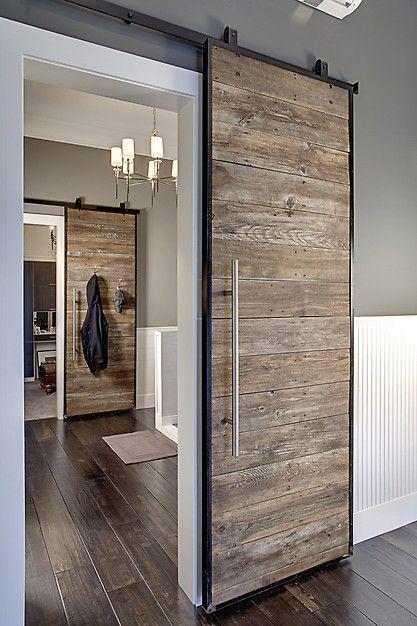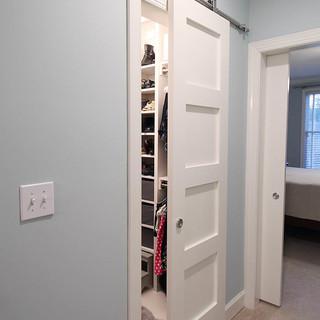The first image is the image on the left, the second image is the image on the right. For the images displayed, is the sentence "The left and right image contains the same number of hanging doors." factually correct? Answer yes or no. No. The first image is the image on the left, the second image is the image on the right. Considering the images on both sides, is "The left image features a 'barn style' door made of weathered-look horizontal wood boards that slides on a black bar at the top." valid? Answer yes or no. Yes. 